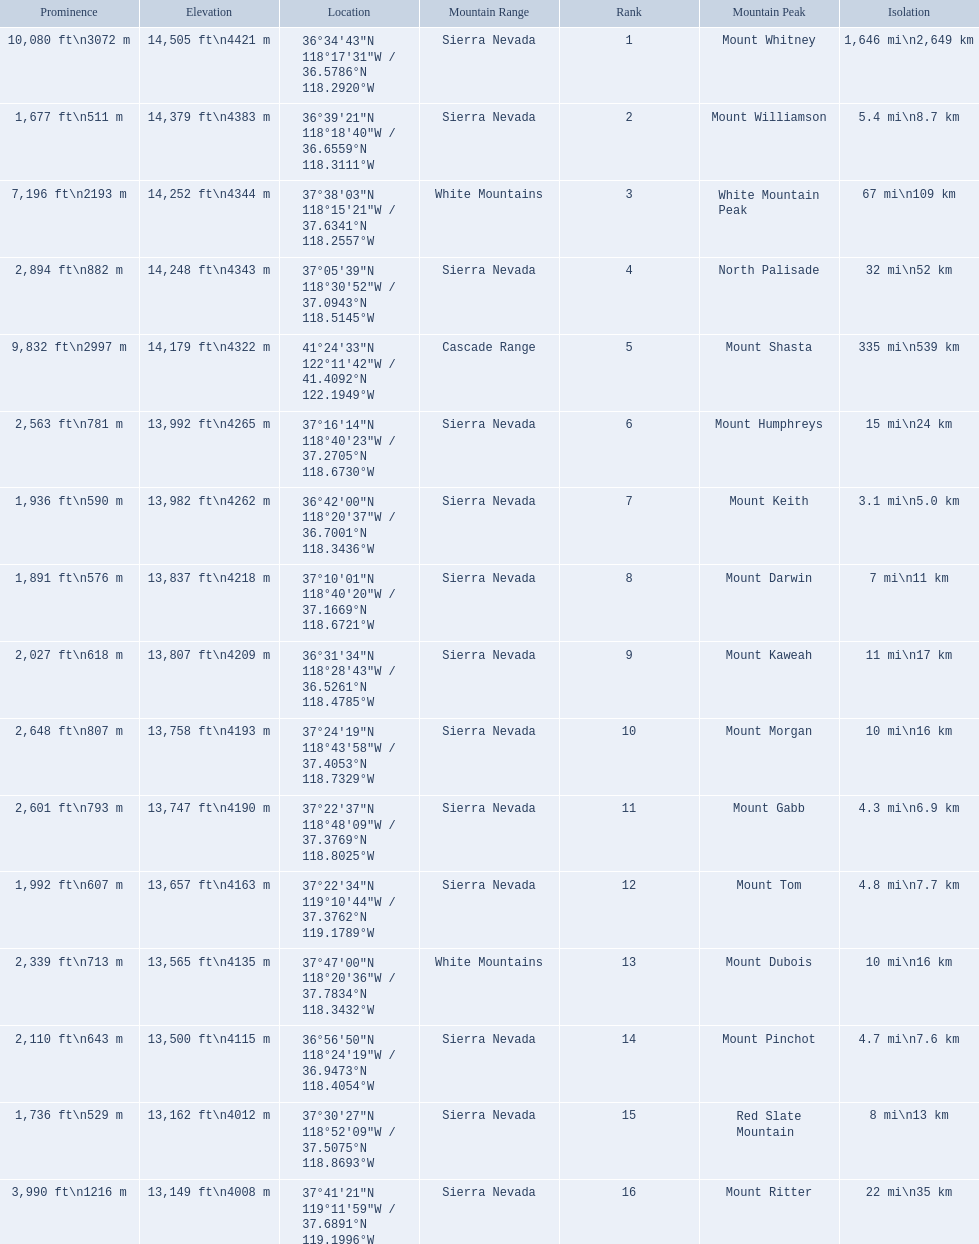Which are the highest mountain peaks in california? Mount Whitney, Mount Williamson, White Mountain Peak, North Palisade, Mount Shasta, Mount Humphreys, Mount Keith, Mount Darwin, Mount Kaweah, Mount Morgan, Mount Gabb, Mount Tom, Mount Dubois, Mount Pinchot, Red Slate Mountain, Mount Ritter. Of those, which are not in the sierra nevada range? White Mountain Peak, Mount Shasta, Mount Dubois. Of the mountains not in the sierra nevada range, which is the only mountain in the cascades? Mount Shasta. 